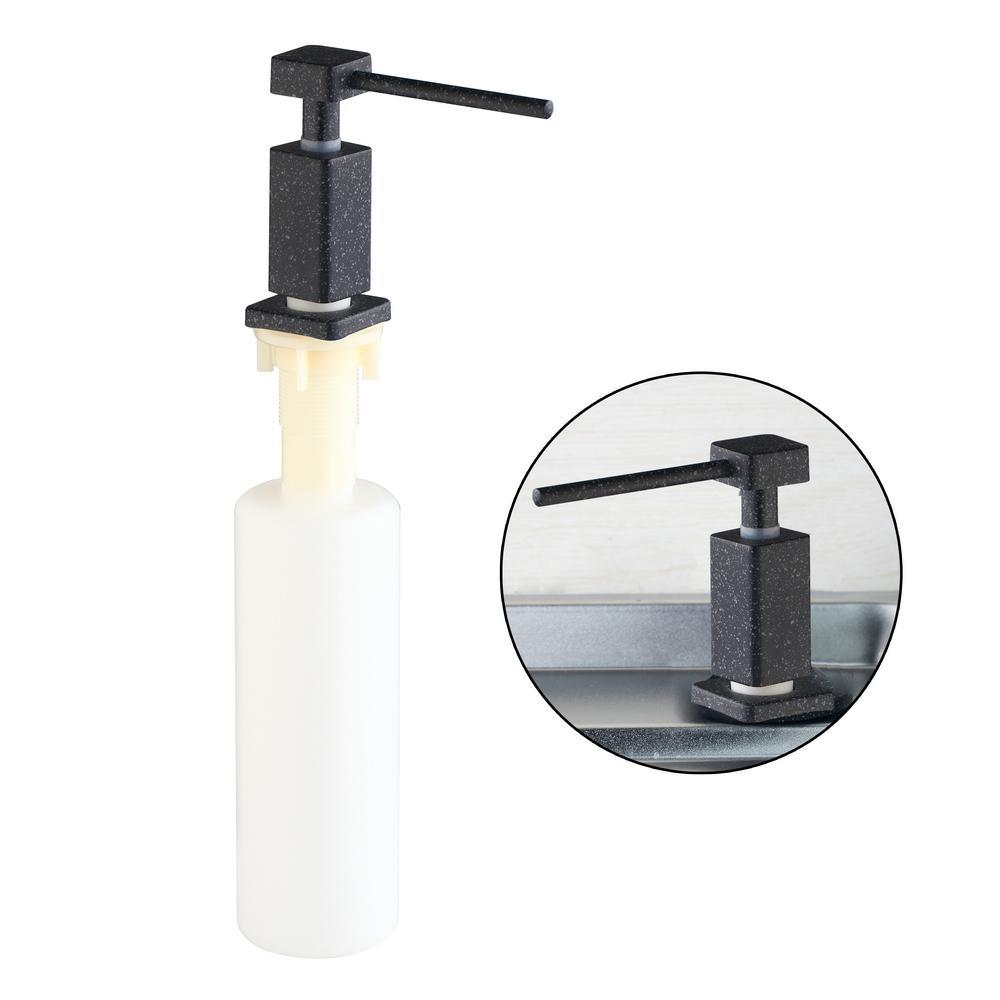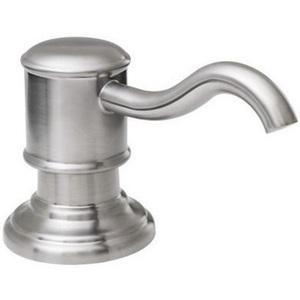The first image is the image on the left, the second image is the image on the right. For the images shown, is this caption "There is a circle-shaped inset image in one or more images." true? Answer yes or no. Yes. 